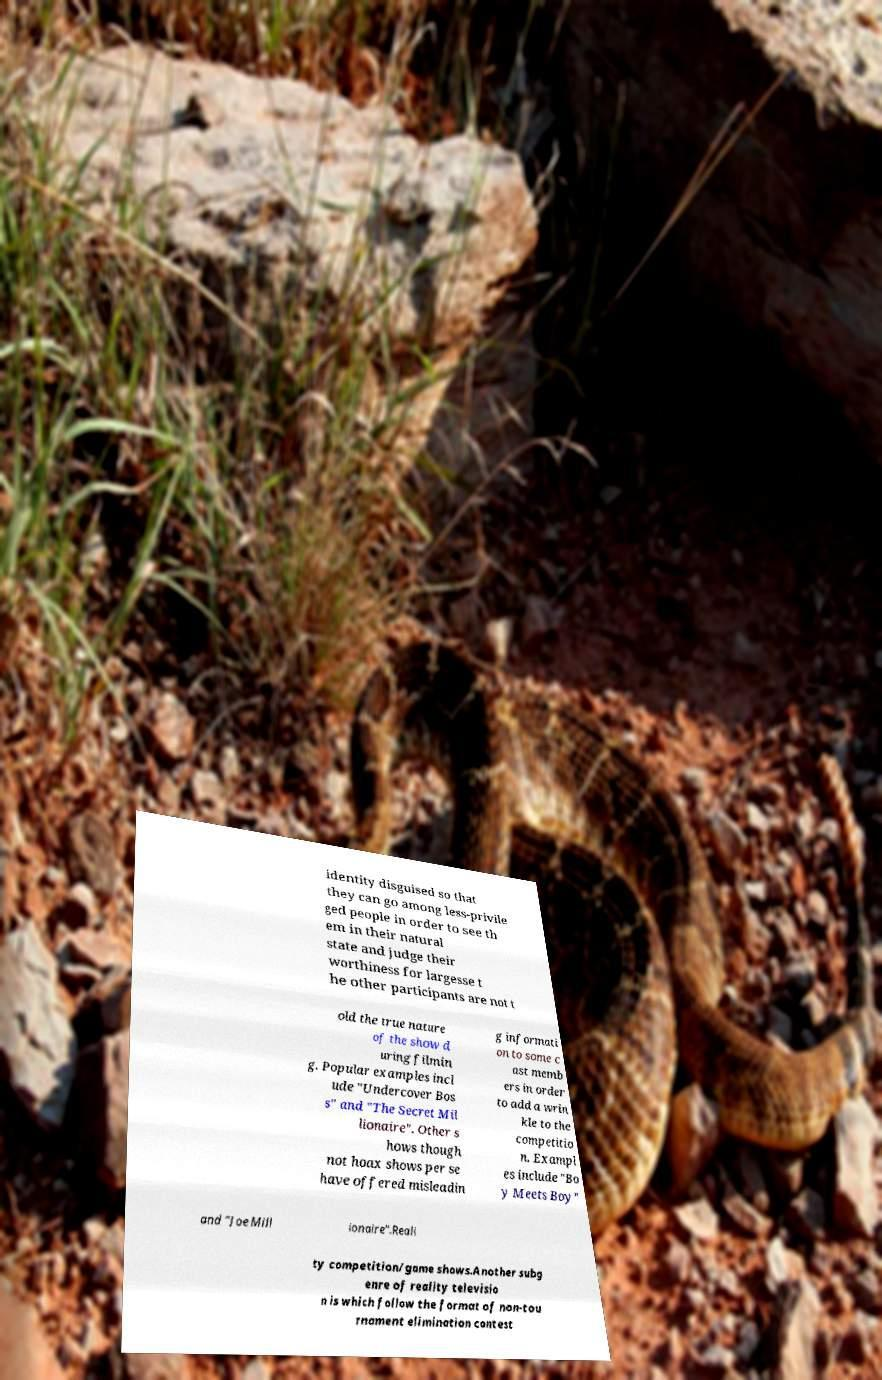Could you extract and type out the text from this image? identity disguised so that they can go among less-privile ged people in order to see th em in their natural state and judge their worthiness for largesse t he other participants are not t old the true nature of the show d uring filmin g. Popular examples incl ude "Undercover Bos s" and "The Secret Mil lionaire". Other s hows though not hoax shows per se have offered misleadin g informati on to some c ast memb ers in order to add a wrin kle to the competitio n. Exampl es include "Bo y Meets Boy" and "Joe Mill ionaire".Reali ty competition/game shows.Another subg enre of reality televisio n is which follow the format of non-tou rnament elimination contest 